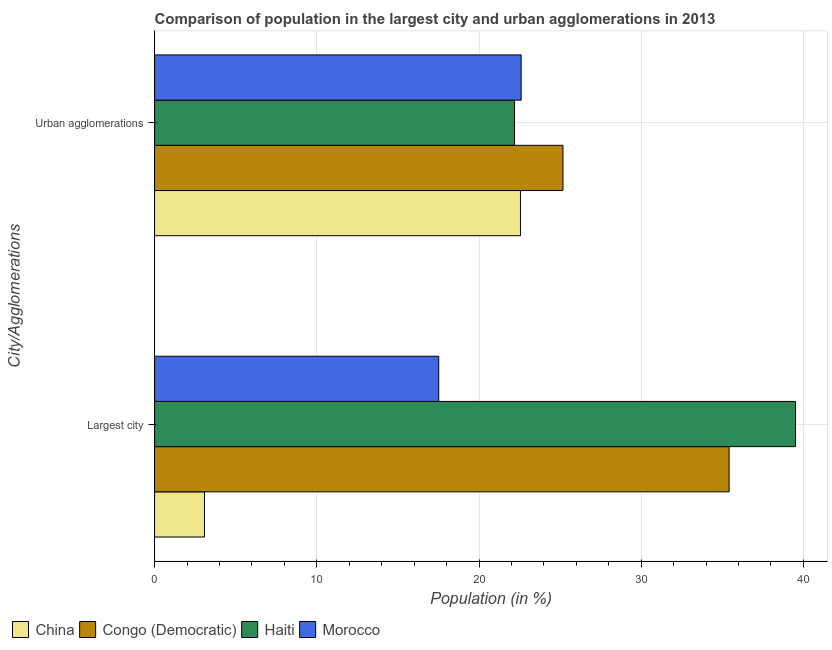How many different coloured bars are there?
Offer a terse response. 4. How many groups of bars are there?
Offer a terse response. 2. Are the number of bars per tick equal to the number of legend labels?
Ensure brevity in your answer.  Yes. How many bars are there on the 1st tick from the top?
Keep it short and to the point. 4. What is the label of the 1st group of bars from the top?
Give a very brief answer. Urban agglomerations. What is the population in urban agglomerations in China?
Give a very brief answer. 22.56. Across all countries, what is the maximum population in urban agglomerations?
Make the answer very short. 25.18. Across all countries, what is the minimum population in urban agglomerations?
Your answer should be very brief. 22.19. In which country was the population in urban agglomerations maximum?
Offer a very short reply. Congo (Democratic). What is the total population in the largest city in the graph?
Ensure brevity in your answer.  95.52. What is the difference between the population in the largest city in Congo (Democratic) and that in China?
Your response must be concise. 32.34. What is the difference between the population in the largest city in Haiti and the population in urban agglomerations in Morocco?
Provide a succinct answer. 16.91. What is the average population in the largest city per country?
Your answer should be very brief. 23.88. What is the difference between the population in the largest city and population in urban agglomerations in China?
Offer a very short reply. -19.48. In how many countries, is the population in the largest city greater than 38 %?
Your response must be concise. 1. What is the ratio of the population in urban agglomerations in Haiti to that in China?
Give a very brief answer. 0.98. In how many countries, is the population in urban agglomerations greater than the average population in urban agglomerations taken over all countries?
Your answer should be compact. 1. What does the 3rd bar from the top in Urban agglomerations represents?
Offer a very short reply. Congo (Democratic). What does the 3rd bar from the bottom in Largest city represents?
Your response must be concise. Haiti. Are all the bars in the graph horizontal?
Keep it short and to the point. Yes. How many countries are there in the graph?
Make the answer very short. 4. Are the values on the major ticks of X-axis written in scientific E-notation?
Ensure brevity in your answer.  No. Does the graph contain any zero values?
Provide a short and direct response. No. Does the graph contain grids?
Your answer should be very brief. Yes. Where does the legend appear in the graph?
Offer a terse response. Bottom left. How many legend labels are there?
Your response must be concise. 4. How are the legend labels stacked?
Provide a succinct answer. Horizontal. What is the title of the graph?
Your answer should be very brief. Comparison of population in the largest city and urban agglomerations in 2013. What is the label or title of the X-axis?
Your response must be concise. Population (in %). What is the label or title of the Y-axis?
Ensure brevity in your answer.  City/Agglomerations. What is the Population (in %) of China in Largest city?
Provide a succinct answer. 3.08. What is the Population (in %) in Congo (Democratic) in Largest city?
Keep it short and to the point. 35.42. What is the Population (in %) in Haiti in Largest city?
Give a very brief answer. 39.51. What is the Population (in %) in Morocco in Largest city?
Your answer should be very brief. 17.52. What is the Population (in %) of China in Urban agglomerations?
Make the answer very short. 22.56. What is the Population (in %) in Congo (Democratic) in Urban agglomerations?
Offer a very short reply. 25.18. What is the Population (in %) of Haiti in Urban agglomerations?
Provide a short and direct response. 22.19. What is the Population (in %) in Morocco in Urban agglomerations?
Offer a very short reply. 22.6. Across all City/Agglomerations, what is the maximum Population (in %) of China?
Provide a succinct answer. 22.56. Across all City/Agglomerations, what is the maximum Population (in %) of Congo (Democratic)?
Make the answer very short. 35.42. Across all City/Agglomerations, what is the maximum Population (in %) in Haiti?
Offer a terse response. 39.51. Across all City/Agglomerations, what is the maximum Population (in %) in Morocco?
Your answer should be very brief. 22.6. Across all City/Agglomerations, what is the minimum Population (in %) in China?
Your answer should be very brief. 3.08. Across all City/Agglomerations, what is the minimum Population (in %) in Congo (Democratic)?
Keep it short and to the point. 25.18. Across all City/Agglomerations, what is the minimum Population (in %) of Haiti?
Offer a terse response. 22.19. Across all City/Agglomerations, what is the minimum Population (in %) of Morocco?
Your answer should be compact. 17.52. What is the total Population (in %) in China in the graph?
Your answer should be compact. 25.63. What is the total Population (in %) of Congo (Democratic) in the graph?
Provide a succinct answer. 60.6. What is the total Population (in %) in Haiti in the graph?
Keep it short and to the point. 61.7. What is the total Population (in %) of Morocco in the graph?
Your answer should be very brief. 40.12. What is the difference between the Population (in %) of China in Largest city and that in Urban agglomerations?
Offer a terse response. -19.48. What is the difference between the Population (in %) of Congo (Democratic) in Largest city and that in Urban agglomerations?
Your answer should be very brief. 10.24. What is the difference between the Population (in %) in Haiti in Largest city and that in Urban agglomerations?
Ensure brevity in your answer.  17.32. What is the difference between the Population (in %) of Morocco in Largest city and that in Urban agglomerations?
Give a very brief answer. -5.08. What is the difference between the Population (in %) in China in Largest city and the Population (in %) in Congo (Democratic) in Urban agglomerations?
Give a very brief answer. -22.1. What is the difference between the Population (in %) in China in Largest city and the Population (in %) in Haiti in Urban agglomerations?
Keep it short and to the point. -19.12. What is the difference between the Population (in %) in China in Largest city and the Population (in %) in Morocco in Urban agglomerations?
Your response must be concise. -19.52. What is the difference between the Population (in %) in Congo (Democratic) in Largest city and the Population (in %) in Haiti in Urban agglomerations?
Your answer should be compact. 13.23. What is the difference between the Population (in %) in Congo (Democratic) in Largest city and the Population (in %) in Morocco in Urban agglomerations?
Provide a succinct answer. 12.82. What is the difference between the Population (in %) of Haiti in Largest city and the Population (in %) of Morocco in Urban agglomerations?
Make the answer very short. 16.91. What is the average Population (in %) in China per City/Agglomerations?
Provide a succinct answer. 12.82. What is the average Population (in %) in Congo (Democratic) per City/Agglomerations?
Keep it short and to the point. 30.3. What is the average Population (in %) in Haiti per City/Agglomerations?
Keep it short and to the point. 30.85. What is the average Population (in %) in Morocco per City/Agglomerations?
Offer a very short reply. 20.06. What is the difference between the Population (in %) in China and Population (in %) in Congo (Democratic) in Largest city?
Provide a short and direct response. -32.34. What is the difference between the Population (in %) in China and Population (in %) in Haiti in Largest city?
Offer a terse response. -36.43. What is the difference between the Population (in %) in China and Population (in %) in Morocco in Largest city?
Ensure brevity in your answer.  -14.44. What is the difference between the Population (in %) of Congo (Democratic) and Population (in %) of Haiti in Largest city?
Offer a very short reply. -4.09. What is the difference between the Population (in %) of Congo (Democratic) and Population (in %) of Morocco in Largest city?
Keep it short and to the point. 17.9. What is the difference between the Population (in %) in Haiti and Population (in %) in Morocco in Largest city?
Provide a short and direct response. 21.99. What is the difference between the Population (in %) of China and Population (in %) of Congo (Democratic) in Urban agglomerations?
Keep it short and to the point. -2.62. What is the difference between the Population (in %) in China and Population (in %) in Haiti in Urban agglomerations?
Provide a succinct answer. 0.36. What is the difference between the Population (in %) of China and Population (in %) of Morocco in Urban agglomerations?
Make the answer very short. -0.04. What is the difference between the Population (in %) of Congo (Democratic) and Population (in %) of Haiti in Urban agglomerations?
Your answer should be compact. 2.99. What is the difference between the Population (in %) in Congo (Democratic) and Population (in %) in Morocco in Urban agglomerations?
Your answer should be compact. 2.58. What is the difference between the Population (in %) in Haiti and Population (in %) in Morocco in Urban agglomerations?
Offer a very short reply. -0.41. What is the ratio of the Population (in %) of China in Largest city to that in Urban agglomerations?
Your answer should be compact. 0.14. What is the ratio of the Population (in %) of Congo (Democratic) in Largest city to that in Urban agglomerations?
Provide a succinct answer. 1.41. What is the ratio of the Population (in %) of Haiti in Largest city to that in Urban agglomerations?
Provide a short and direct response. 1.78. What is the ratio of the Population (in %) of Morocco in Largest city to that in Urban agglomerations?
Provide a succinct answer. 0.78. What is the difference between the highest and the second highest Population (in %) in China?
Ensure brevity in your answer.  19.48. What is the difference between the highest and the second highest Population (in %) in Congo (Democratic)?
Your answer should be very brief. 10.24. What is the difference between the highest and the second highest Population (in %) of Haiti?
Your answer should be very brief. 17.32. What is the difference between the highest and the second highest Population (in %) of Morocco?
Offer a terse response. 5.08. What is the difference between the highest and the lowest Population (in %) of China?
Give a very brief answer. 19.48. What is the difference between the highest and the lowest Population (in %) in Congo (Democratic)?
Make the answer very short. 10.24. What is the difference between the highest and the lowest Population (in %) of Haiti?
Give a very brief answer. 17.32. What is the difference between the highest and the lowest Population (in %) of Morocco?
Keep it short and to the point. 5.08. 